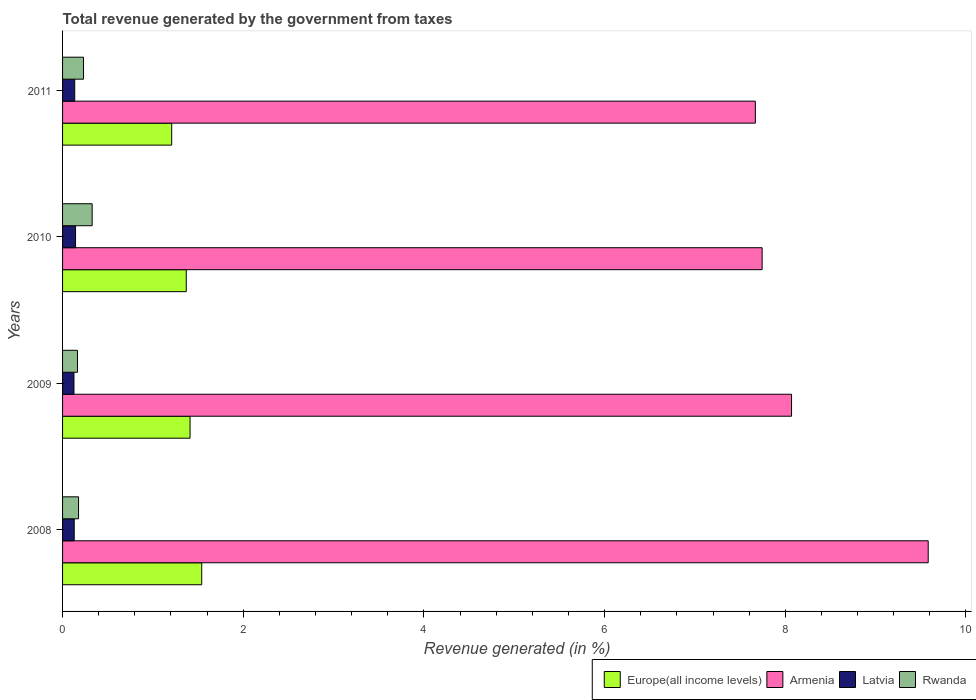How many groups of bars are there?
Your answer should be compact. 4. Are the number of bars on each tick of the Y-axis equal?
Your answer should be compact. Yes. How many bars are there on the 4th tick from the top?
Provide a short and direct response. 4. How many bars are there on the 1st tick from the bottom?
Your answer should be compact. 4. What is the label of the 1st group of bars from the top?
Give a very brief answer. 2011. In how many cases, is the number of bars for a given year not equal to the number of legend labels?
Keep it short and to the point. 0. What is the total revenue generated in Rwanda in 2008?
Give a very brief answer. 0.18. Across all years, what is the maximum total revenue generated in Armenia?
Give a very brief answer. 9.58. Across all years, what is the minimum total revenue generated in Europe(all income levels)?
Your answer should be compact. 1.21. In which year was the total revenue generated in Armenia minimum?
Keep it short and to the point. 2011. What is the total total revenue generated in Rwanda in the graph?
Give a very brief answer. 0.9. What is the difference between the total revenue generated in Rwanda in 2008 and that in 2009?
Provide a succinct answer. 0.01. What is the difference between the total revenue generated in Armenia in 2009 and the total revenue generated in Latvia in 2008?
Provide a succinct answer. 7.94. What is the average total revenue generated in Armenia per year?
Your answer should be very brief. 8.27. In the year 2009, what is the difference between the total revenue generated in Armenia and total revenue generated in Europe(all income levels)?
Make the answer very short. 6.66. In how many years, is the total revenue generated in Armenia greater than 5.2 %?
Ensure brevity in your answer.  4. What is the ratio of the total revenue generated in Latvia in 2009 to that in 2011?
Offer a very short reply. 0.94. What is the difference between the highest and the second highest total revenue generated in Europe(all income levels)?
Give a very brief answer. 0.13. What is the difference between the highest and the lowest total revenue generated in Armenia?
Provide a succinct answer. 1.91. Is it the case that in every year, the sum of the total revenue generated in Latvia and total revenue generated in Armenia is greater than the sum of total revenue generated in Rwanda and total revenue generated in Europe(all income levels)?
Offer a very short reply. Yes. What does the 4th bar from the top in 2011 represents?
Your answer should be very brief. Europe(all income levels). What does the 1st bar from the bottom in 2010 represents?
Your answer should be very brief. Europe(all income levels). Is it the case that in every year, the sum of the total revenue generated in Armenia and total revenue generated in Europe(all income levels) is greater than the total revenue generated in Rwanda?
Your response must be concise. Yes. How many bars are there?
Your answer should be very brief. 16. Are all the bars in the graph horizontal?
Provide a succinct answer. Yes. What is the difference between two consecutive major ticks on the X-axis?
Provide a succinct answer. 2. Does the graph contain any zero values?
Make the answer very short. No. Does the graph contain grids?
Your response must be concise. No. How many legend labels are there?
Provide a succinct answer. 4. What is the title of the graph?
Make the answer very short. Total revenue generated by the government from taxes. Does "Cuba" appear as one of the legend labels in the graph?
Give a very brief answer. No. What is the label or title of the X-axis?
Your response must be concise. Revenue generated (in %). What is the label or title of the Y-axis?
Keep it short and to the point. Years. What is the Revenue generated (in %) of Europe(all income levels) in 2008?
Ensure brevity in your answer.  1.54. What is the Revenue generated (in %) in Armenia in 2008?
Keep it short and to the point. 9.58. What is the Revenue generated (in %) in Latvia in 2008?
Offer a very short reply. 0.13. What is the Revenue generated (in %) of Rwanda in 2008?
Make the answer very short. 0.18. What is the Revenue generated (in %) of Europe(all income levels) in 2009?
Offer a terse response. 1.41. What is the Revenue generated (in %) in Armenia in 2009?
Provide a succinct answer. 8.07. What is the Revenue generated (in %) of Latvia in 2009?
Provide a short and direct response. 0.13. What is the Revenue generated (in %) of Rwanda in 2009?
Your answer should be very brief. 0.17. What is the Revenue generated (in %) in Europe(all income levels) in 2010?
Ensure brevity in your answer.  1.37. What is the Revenue generated (in %) in Armenia in 2010?
Your answer should be very brief. 7.74. What is the Revenue generated (in %) of Latvia in 2010?
Provide a succinct answer. 0.14. What is the Revenue generated (in %) of Rwanda in 2010?
Offer a very short reply. 0.33. What is the Revenue generated (in %) in Europe(all income levels) in 2011?
Make the answer very short. 1.21. What is the Revenue generated (in %) in Armenia in 2011?
Offer a terse response. 7.67. What is the Revenue generated (in %) in Latvia in 2011?
Provide a succinct answer. 0.13. What is the Revenue generated (in %) of Rwanda in 2011?
Make the answer very short. 0.23. Across all years, what is the maximum Revenue generated (in %) in Europe(all income levels)?
Your answer should be very brief. 1.54. Across all years, what is the maximum Revenue generated (in %) in Armenia?
Ensure brevity in your answer.  9.58. Across all years, what is the maximum Revenue generated (in %) in Latvia?
Provide a short and direct response. 0.14. Across all years, what is the maximum Revenue generated (in %) in Rwanda?
Make the answer very short. 0.33. Across all years, what is the minimum Revenue generated (in %) of Europe(all income levels)?
Give a very brief answer. 1.21. Across all years, what is the minimum Revenue generated (in %) of Armenia?
Your answer should be compact. 7.67. Across all years, what is the minimum Revenue generated (in %) in Latvia?
Your answer should be very brief. 0.13. Across all years, what is the minimum Revenue generated (in %) of Rwanda?
Keep it short and to the point. 0.17. What is the total Revenue generated (in %) in Europe(all income levels) in the graph?
Your answer should be very brief. 5.53. What is the total Revenue generated (in %) of Armenia in the graph?
Keep it short and to the point. 33.06. What is the total Revenue generated (in %) of Latvia in the graph?
Your answer should be very brief. 0.53. What is the total Revenue generated (in %) of Rwanda in the graph?
Ensure brevity in your answer.  0.9. What is the difference between the Revenue generated (in %) in Europe(all income levels) in 2008 and that in 2009?
Provide a succinct answer. 0.13. What is the difference between the Revenue generated (in %) in Armenia in 2008 and that in 2009?
Ensure brevity in your answer.  1.51. What is the difference between the Revenue generated (in %) of Latvia in 2008 and that in 2009?
Offer a very short reply. 0. What is the difference between the Revenue generated (in %) of Rwanda in 2008 and that in 2009?
Your response must be concise. 0.01. What is the difference between the Revenue generated (in %) of Europe(all income levels) in 2008 and that in 2010?
Keep it short and to the point. 0.17. What is the difference between the Revenue generated (in %) of Armenia in 2008 and that in 2010?
Your answer should be very brief. 1.84. What is the difference between the Revenue generated (in %) in Latvia in 2008 and that in 2010?
Make the answer very short. -0.01. What is the difference between the Revenue generated (in %) in Rwanda in 2008 and that in 2010?
Provide a short and direct response. -0.15. What is the difference between the Revenue generated (in %) of Europe(all income levels) in 2008 and that in 2011?
Keep it short and to the point. 0.33. What is the difference between the Revenue generated (in %) in Armenia in 2008 and that in 2011?
Provide a short and direct response. 1.91. What is the difference between the Revenue generated (in %) in Latvia in 2008 and that in 2011?
Your answer should be compact. -0.01. What is the difference between the Revenue generated (in %) of Rwanda in 2008 and that in 2011?
Give a very brief answer. -0.06. What is the difference between the Revenue generated (in %) of Europe(all income levels) in 2009 and that in 2010?
Make the answer very short. 0.04. What is the difference between the Revenue generated (in %) in Armenia in 2009 and that in 2010?
Your answer should be very brief. 0.33. What is the difference between the Revenue generated (in %) in Latvia in 2009 and that in 2010?
Offer a terse response. -0.02. What is the difference between the Revenue generated (in %) of Rwanda in 2009 and that in 2010?
Offer a terse response. -0.16. What is the difference between the Revenue generated (in %) of Europe(all income levels) in 2009 and that in 2011?
Provide a succinct answer. 0.2. What is the difference between the Revenue generated (in %) of Armenia in 2009 and that in 2011?
Keep it short and to the point. 0.4. What is the difference between the Revenue generated (in %) of Latvia in 2009 and that in 2011?
Your response must be concise. -0.01. What is the difference between the Revenue generated (in %) in Rwanda in 2009 and that in 2011?
Provide a succinct answer. -0.07. What is the difference between the Revenue generated (in %) of Europe(all income levels) in 2010 and that in 2011?
Make the answer very short. 0.16. What is the difference between the Revenue generated (in %) of Armenia in 2010 and that in 2011?
Your answer should be compact. 0.07. What is the difference between the Revenue generated (in %) in Latvia in 2010 and that in 2011?
Provide a succinct answer. 0.01. What is the difference between the Revenue generated (in %) of Rwanda in 2010 and that in 2011?
Provide a short and direct response. 0.1. What is the difference between the Revenue generated (in %) in Europe(all income levels) in 2008 and the Revenue generated (in %) in Armenia in 2009?
Your response must be concise. -6.53. What is the difference between the Revenue generated (in %) of Europe(all income levels) in 2008 and the Revenue generated (in %) of Latvia in 2009?
Your answer should be very brief. 1.41. What is the difference between the Revenue generated (in %) of Europe(all income levels) in 2008 and the Revenue generated (in %) of Rwanda in 2009?
Provide a succinct answer. 1.38. What is the difference between the Revenue generated (in %) in Armenia in 2008 and the Revenue generated (in %) in Latvia in 2009?
Offer a very short reply. 9.46. What is the difference between the Revenue generated (in %) in Armenia in 2008 and the Revenue generated (in %) in Rwanda in 2009?
Your response must be concise. 9.42. What is the difference between the Revenue generated (in %) in Latvia in 2008 and the Revenue generated (in %) in Rwanda in 2009?
Give a very brief answer. -0.04. What is the difference between the Revenue generated (in %) of Europe(all income levels) in 2008 and the Revenue generated (in %) of Armenia in 2010?
Your response must be concise. -6.2. What is the difference between the Revenue generated (in %) in Europe(all income levels) in 2008 and the Revenue generated (in %) in Latvia in 2010?
Your response must be concise. 1.4. What is the difference between the Revenue generated (in %) of Europe(all income levels) in 2008 and the Revenue generated (in %) of Rwanda in 2010?
Give a very brief answer. 1.21. What is the difference between the Revenue generated (in %) in Armenia in 2008 and the Revenue generated (in %) in Latvia in 2010?
Offer a very short reply. 9.44. What is the difference between the Revenue generated (in %) in Armenia in 2008 and the Revenue generated (in %) in Rwanda in 2010?
Give a very brief answer. 9.25. What is the difference between the Revenue generated (in %) in Latvia in 2008 and the Revenue generated (in %) in Rwanda in 2010?
Give a very brief answer. -0.2. What is the difference between the Revenue generated (in %) of Europe(all income levels) in 2008 and the Revenue generated (in %) of Armenia in 2011?
Keep it short and to the point. -6.13. What is the difference between the Revenue generated (in %) in Europe(all income levels) in 2008 and the Revenue generated (in %) in Latvia in 2011?
Your answer should be compact. 1.41. What is the difference between the Revenue generated (in %) of Europe(all income levels) in 2008 and the Revenue generated (in %) of Rwanda in 2011?
Provide a succinct answer. 1.31. What is the difference between the Revenue generated (in %) of Armenia in 2008 and the Revenue generated (in %) of Latvia in 2011?
Your response must be concise. 9.45. What is the difference between the Revenue generated (in %) in Armenia in 2008 and the Revenue generated (in %) in Rwanda in 2011?
Provide a short and direct response. 9.35. What is the difference between the Revenue generated (in %) in Latvia in 2008 and the Revenue generated (in %) in Rwanda in 2011?
Your answer should be compact. -0.1. What is the difference between the Revenue generated (in %) of Europe(all income levels) in 2009 and the Revenue generated (in %) of Armenia in 2010?
Offer a terse response. -6.33. What is the difference between the Revenue generated (in %) of Europe(all income levels) in 2009 and the Revenue generated (in %) of Latvia in 2010?
Provide a short and direct response. 1.27. What is the difference between the Revenue generated (in %) in Europe(all income levels) in 2009 and the Revenue generated (in %) in Rwanda in 2010?
Your answer should be compact. 1.08. What is the difference between the Revenue generated (in %) of Armenia in 2009 and the Revenue generated (in %) of Latvia in 2010?
Give a very brief answer. 7.93. What is the difference between the Revenue generated (in %) of Armenia in 2009 and the Revenue generated (in %) of Rwanda in 2010?
Offer a terse response. 7.74. What is the difference between the Revenue generated (in %) in Latvia in 2009 and the Revenue generated (in %) in Rwanda in 2010?
Your answer should be very brief. -0.2. What is the difference between the Revenue generated (in %) in Europe(all income levels) in 2009 and the Revenue generated (in %) in Armenia in 2011?
Provide a short and direct response. -6.26. What is the difference between the Revenue generated (in %) of Europe(all income levels) in 2009 and the Revenue generated (in %) of Latvia in 2011?
Offer a very short reply. 1.28. What is the difference between the Revenue generated (in %) in Europe(all income levels) in 2009 and the Revenue generated (in %) in Rwanda in 2011?
Make the answer very short. 1.18. What is the difference between the Revenue generated (in %) of Armenia in 2009 and the Revenue generated (in %) of Latvia in 2011?
Your response must be concise. 7.93. What is the difference between the Revenue generated (in %) in Armenia in 2009 and the Revenue generated (in %) in Rwanda in 2011?
Provide a short and direct response. 7.84. What is the difference between the Revenue generated (in %) in Latvia in 2009 and the Revenue generated (in %) in Rwanda in 2011?
Keep it short and to the point. -0.11. What is the difference between the Revenue generated (in %) in Europe(all income levels) in 2010 and the Revenue generated (in %) in Armenia in 2011?
Your answer should be compact. -6.3. What is the difference between the Revenue generated (in %) in Europe(all income levels) in 2010 and the Revenue generated (in %) in Latvia in 2011?
Keep it short and to the point. 1.23. What is the difference between the Revenue generated (in %) of Europe(all income levels) in 2010 and the Revenue generated (in %) of Rwanda in 2011?
Your answer should be very brief. 1.14. What is the difference between the Revenue generated (in %) of Armenia in 2010 and the Revenue generated (in %) of Latvia in 2011?
Your answer should be compact. 7.61. What is the difference between the Revenue generated (in %) in Armenia in 2010 and the Revenue generated (in %) in Rwanda in 2011?
Offer a terse response. 7.51. What is the difference between the Revenue generated (in %) in Latvia in 2010 and the Revenue generated (in %) in Rwanda in 2011?
Provide a short and direct response. -0.09. What is the average Revenue generated (in %) of Europe(all income levels) per year?
Your response must be concise. 1.38. What is the average Revenue generated (in %) in Armenia per year?
Provide a short and direct response. 8.27. What is the average Revenue generated (in %) of Latvia per year?
Give a very brief answer. 0.13. What is the average Revenue generated (in %) of Rwanda per year?
Keep it short and to the point. 0.23. In the year 2008, what is the difference between the Revenue generated (in %) of Europe(all income levels) and Revenue generated (in %) of Armenia?
Make the answer very short. -8.04. In the year 2008, what is the difference between the Revenue generated (in %) in Europe(all income levels) and Revenue generated (in %) in Latvia?
Give a very brief answer. 1.41. In the year 2008, what is the difference between the Revenue generated (in %) of Europe(all income levels) and Revenue generated (in %) of Rwanda?
Provide a short and direct response. 1.36. In the year 2008, what is the difference between the Revenue generated (in %) in Armenia and Revenue generated (in %) in Latvia?
Offer a very short reply. 9.45. In the year 2008, what is the difference between the Revenue generated (in %) in Armenia and Revenue generated (in %) in Rwanda?
Your answer should be compact. 9.41. In the year 2008, what is the difference between the Revenue generated (in %) in Latvia and Revenue generated (in %) in Rwanda?
Ensure brevity in your answer.  -0.05. In the year 2009, what is the difference between the Revenue generated (in %) in Europe(all income levels) and Revenue generated (in %) in Armenia?
Keep it short and to the point. -6.66. In the year 2009, what is the difference between the Revenue generated (in %) of Europe(all income levels) and Revenue generated (in %) of Latvia?
Your response must be concise. 1.28. In the year 2009, what is the difference between the Revenue generated (in %) in Europe(all income levels) and Revenue generated (in %) in Rwanda?
Provide a succinct answer. 1.25. In the year 2009, what is the difference between the Revenue generated (in %) of Armenia and Revenue generated (in %) of Latvia?
Keep it short and to the point. 7.94. In the year 2009, what is the difference between the Revenue generated (in %) of Armenia and Revenue generated (in %) of Rwanda?
Provide a short and direct response. 7.9. In the year 2009, what is the difference between the Revenue generated (in %) in Latvia and Revenue generated (in %) in Rwanda?
Your answer should be compact. -0.04. In the year 2010, what is the difference between the Revenue generated (in %) in Europe(all income levels) and Revenue generated (in %) in Armenia?
Provide a succinct answer. -6.37. In the year 2010, what is the difference between the Revenue generated (in %) in Europe(all income levels) and Revenue generated (in %) in Latvia?
Your response must be concise. 1.23. In the year 2010, what is the difference between the Revenue generated (in %) in Europe(all income levels) and Revenue generated (in %) in Rwanda?
Your answer should be compact. 1.04. In the year 2010, what is the difference between the Revenue generated (in %) of Armenia and Revenue generated (in %) of Latvia?
Make the answer very short. 7.6. In the year 2010, what is the difference between the Revenue generated (in %) of Armenia and Revenue generated (in %) of Rwanda?
Offer a very short reply. 7.42. In the year 2010, what is the difference between the Revenue generated (in %) of Latvia and Revenue generated (in %) of Rwanda?
Give a very brief answer. -0.18. In the year 2011, what is the difference between the Revenue generated (in %) of Europe(all income levels) and Revenue generated (in %) of Armenia?
Offer a very short reply. -6.46. In the year 2011, what is the difference between the Revenue generated (in %) in Europe(all income levels) and Revenue generated (in %) in Latvia?
Provide a short and direct response. 1.07. In the year 2011, what is the difference between the Revenue generated (in %) of Europe(all income levels) and Revenue generated (in %) of Rwanda?
Your response must be concise. 0.98. In the year 2011, what is the difference between the Revenue generated (in %) of Armenia and Revenue generated (in %) of Latvia?
Give a very brief answer. 7.53. In the year 2011, what is the difference between the Revenue generated (in %) of Armenia and Revenue generated (in %) of Rwanda?
Make the answer very short. 7.44. In the year 2011, what is the difference between the Revenue generated (in %) in Latvia and Revenue generated (in %) in Rwanda?
Ensure brevity in your answer.  -0.1. What is the ratio of the Revenue generated (in %) in Europe(all income levels) in 2008 to that in 2009?
Offer a very short reply. 1.09. What is the ratio of the Revenue generated (in %) in Armenia in 2008 to that in 2009?
Your response must be concise. 1.19. What is the ratio of the Revenue generated (in %) in Latvia in 2008 to that in 2009?
Ensure brevity in your answer.  1.02. What is the ratio of the Revenue generated (in %) in Rwanda in 2008 to that in 2009?
Offer a terse response. 1.07. What is the ratio of the Revenue generated (in %) in Europe(all income levels) in 2008 to that in 2010?
Ensure brevity in your answer.  1.13. What is the ratio of the Revenue generated (in %) of Armenia in 2008 to that in 2010?
Your answer should be compact. 1.24. What is the ratio of the Revenue generated (in %) of Latvia in 2008 to that in 2010?
Keep it short and to the point. 0.9. What is the ratio of the Revenue generated (in %) in Rwanda in 2008 to that in 2010?
Your answer should be compact. 0.54. What is the ratio of the Revenue generated (in %) of Europe(all income levels) in 2008 to that in 2011?
Offer a terse response. 1.28. What is the ratio of the Revenue generated (in %) of Armenia in 2008 to that in 2011?
Your response must be concise. 1.25. What is the ratio of the Revenue generated (in %) in Latvia in 2008 to that in 2011?
Ensure brevity in your answer.  0.96. What is the ratio of the Revenue generated (in %) of Rwanda in 2008 to that in 2011?
Ensure brevity in your answer.  0.76. What is the ratio of the Revenue generated (in %) of Europe(all income levels) in 2009 to that in 2010?
Ensure brevity in your answer.  1.03. What is the ratio of the Revenue generated (in %) in Armenia in 2009 to that in 2010?
Your answer should be compact. 1.04. What is the ratio of the Revenue generated (in %) of Latvia in 2009 to that in 2010?
Your answer should be very brief. 0.88. What is the ratio of the Revenue generated (in %) of Rwanda in 2009 to that in 2010?
Offer a terse response. 0.5. What is the ratio of the Revenue generated (in %) of Europe(all income levels) in 2009 to that in 2011?
Offer a very short reply. 1.17. What is the ratio of the Revenue generated (in %) of Armenia in 2009 to that in 2011?
Provide a succinct answer. 1.05. What is the ratio of the Revenue generated (in %) of Latvia in 2009 to that in 2011?
Provide a short and direct response. 0.94. What is the ratio of the Revenue generated (in %) in Rwanda in 2009 to that in 2011?
Make the answer very short. 0.71. What is the ratio of the Revenue generated (in %) of Europe(all income levels) in 2010 to that in 2011?
Offer a terse response. 1.13. What is the ratio of the Revenue generated (in %) of Armenia in 2010 to that in 2011?
Your response must be concise. 1.01. What is the ratio of the Revenue generated (in %) in Latvia in 2010 to that in 2011?
Offer a terse response. 1.07. What is the ratio of the Revenue generated (in %) in Rwanda in 2010 to that in 2011?
Keep it short and to the point. 1.41. What is the difference between the highest and the second highest Revenue generated (in %) of Europe(all income levels)?
Keep it short and to the point. 0.13. What is the difference between the highest and the second highest Revenue generated (in %) in Armenia?
Offer a terse response. 1.51. What is the difference between the highest and the second highest Revenue generated (in %) of Latvia?
Ensure brevity in your answer.  0.01. What is the difference between the highest and the second highest Revenue generated (in %) of Rwanda?
Your response must be concise. 0.1. What is the difference between the highest and the lowest Revenue generated (in %) in Europe(all income levels)?
Offer a very short reply. 0.33. What is the difference between the highest and the lowest Revenue generated (in %) in Armenia?
Give a very brief answer. 1.91. What is the difference between the highest and the lowest Revenue generated (in %) in Latvia?
Make the answer very short. 0.02. What is the difference between the highest and the lowest Revenue generated (in %) in Rwanda?
Give a very brief answer. 0.16. 